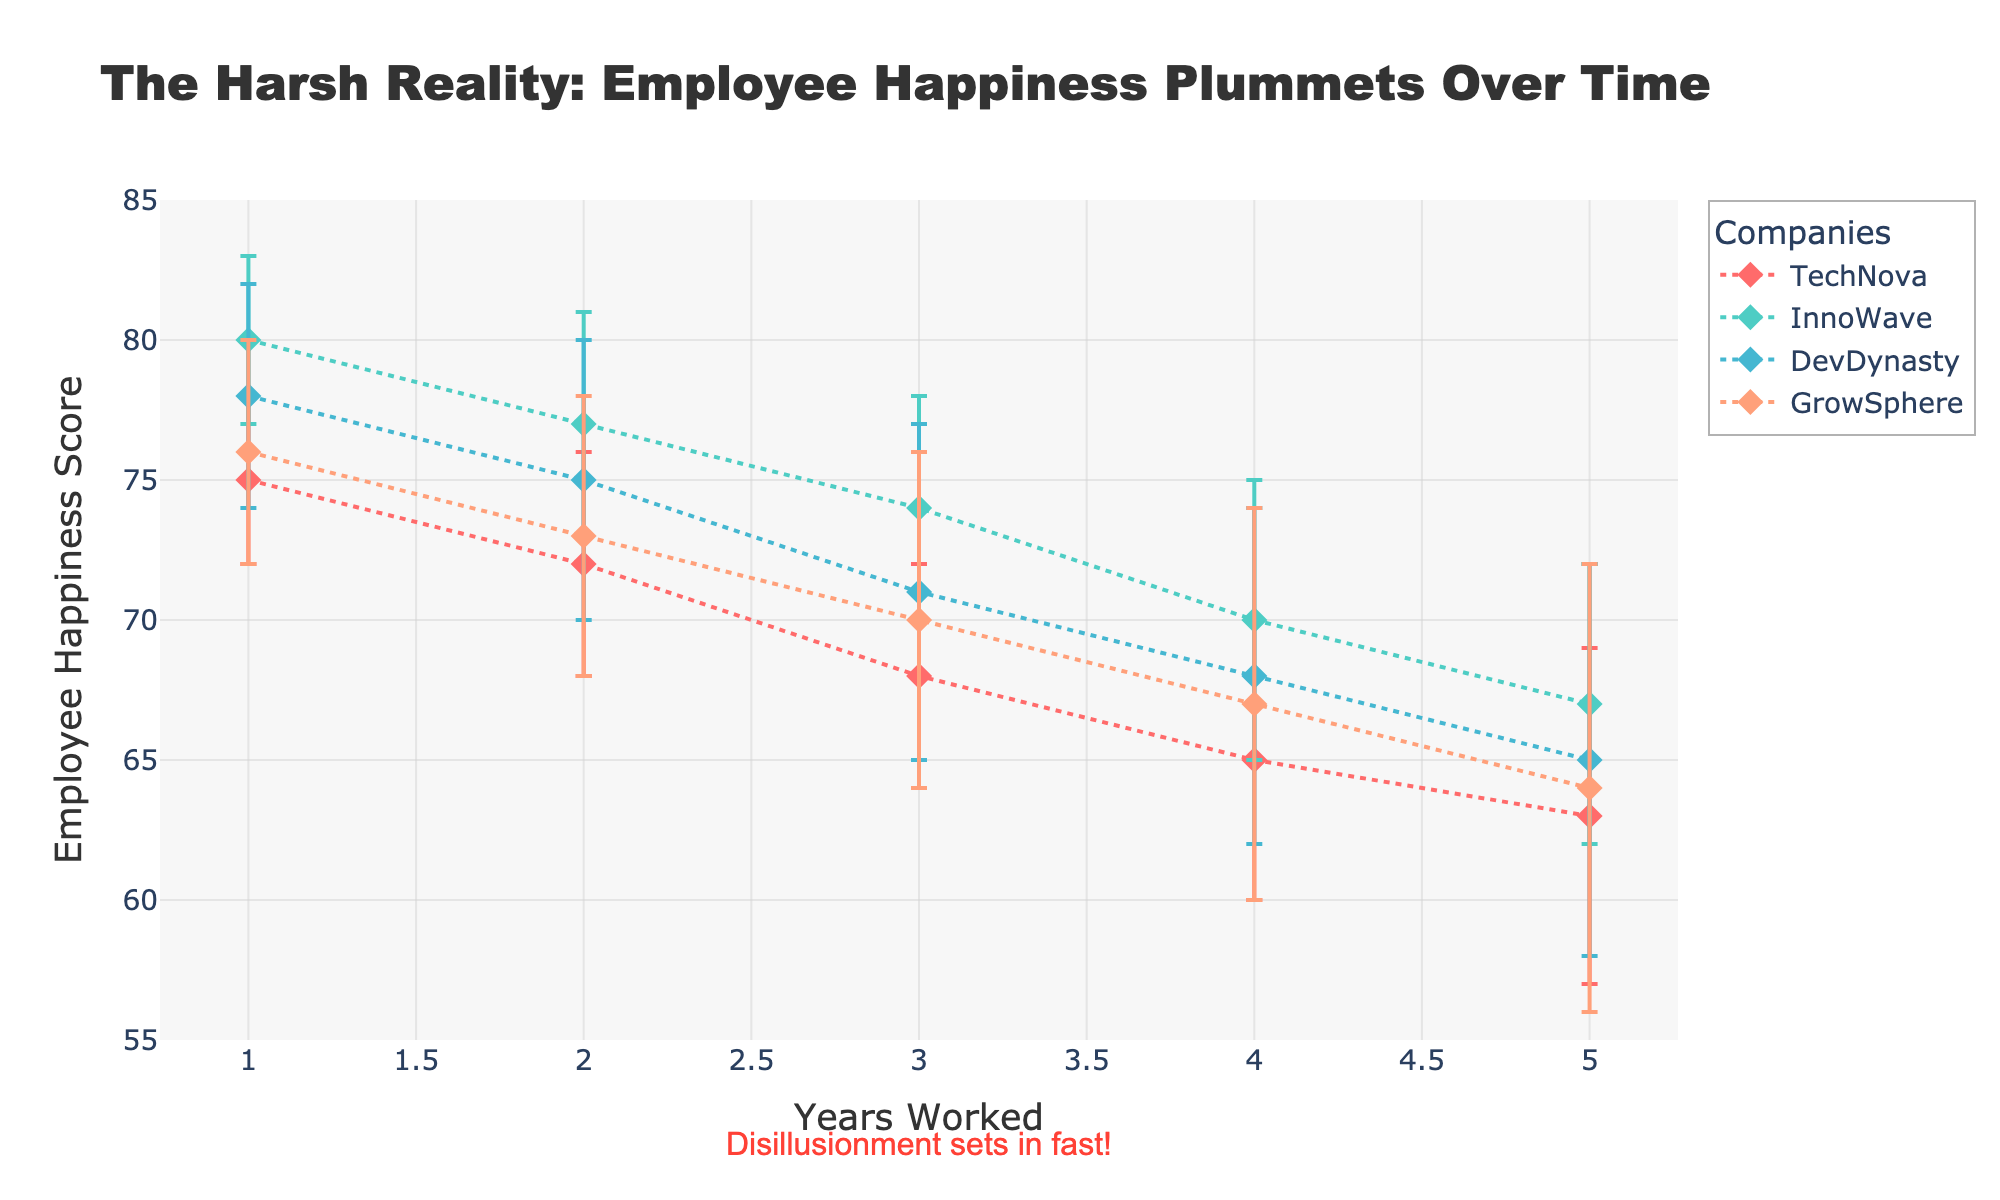what is the title of the figure? The title is displayed at the top of the figure. It reads "The Harsh Reality: Employee Happiness Plummets Over Time".
Answer: The Harsh Reality: Employee Happiness Plummets Over Time what is the x-axis labeled? The label of the x-axis is mentioned beside it. It is titled "Years Worked".
Answer: Years Worked how many companies are compared in the plot? There are four unique colors and legend labels representing different companies. These are TechNova, InnoWave, DevDynasty, and GrowSphere.
Answer: Four for InnoWave, what is the employee happiness score after 3 years worked? The dot for InnoWave at 3 years on the x-axis marks 74 for employee happiness on the y-axis.
Answer: 74 which company shows the steepest decline in employee happiness from year 1 to year 5? By comparing the slopes of the lines for each company, TechNova shows the steepest decline, going from 75 to 63.
Answer: TechNova which company has the highest employee happiness in year 1? The dot for each company at 1 year is compared. InnoWave is the highest with a score of 80.
Answer: InnoWave what is the average employee happiness score for GrowSphere over the years? Averaging GrowSphere's scores: (76+73+70+67+64)/5 = 70.
Answer: 70 between year 2 and year 4, which company has the smallest range in employee happiness? DevDynasty shows the smallest range: from 75 to 68, a difference of 7.
Answer: DevDynasty referring to TechNova, what is the width of the error bar at year 2? From the lower bound (68) to the upper bound (76), the range is 8.
Answer: 8 compare the trend of employee happiness between TechNova and GrowSphere over the years. Both show a declining trend, but TechNova's decline is steeper, especially after year 2, compared to the more gradual decline of GrowSphere.
Answer: steep decline versus gradual decline 